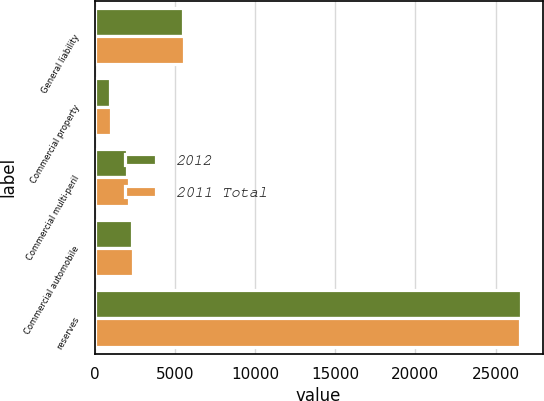Convert chart. <chart><loc_0><loc_0><loc_500><loc_500><stacked_bar_chart><ecel><fcel>General liability<fcel>Commercial property<fcel>Commercial multi-peril<fcel>Commercial automobile<fcel>reserves<nl><fcel>2012<fcel>5525<fcel>992<fcel>2018<fcel>2343<fcel>26606<nl><fcel>2011 Total<fcel>5571<fcel>1025<fcel>2153<fcel>2388<fcel>26511<nl></chart> 